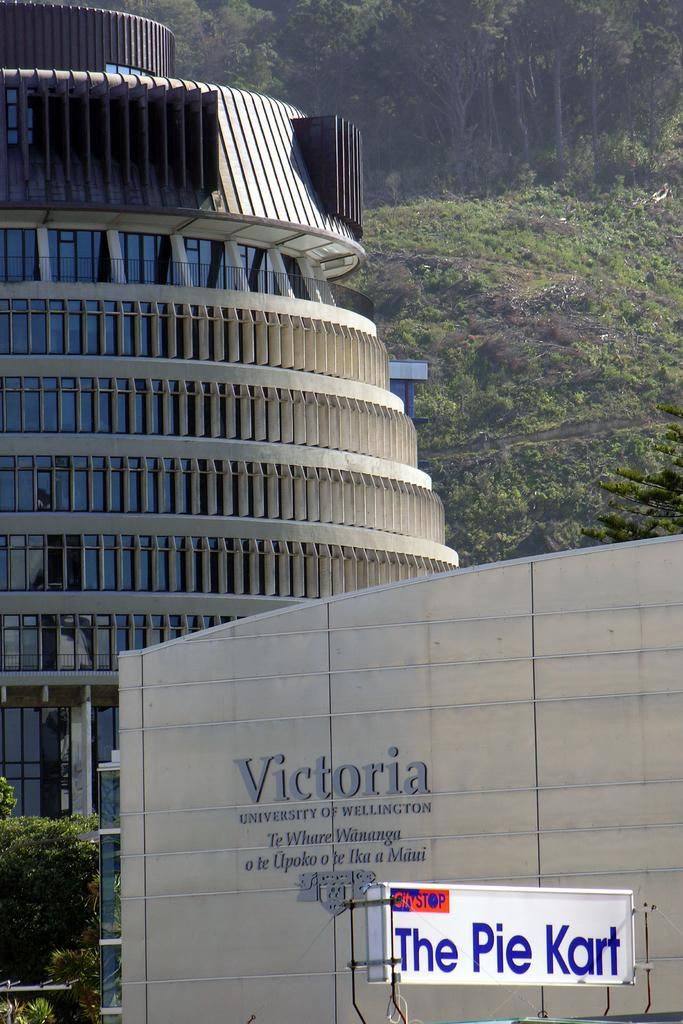What type of structures can be seen in the image? There are buildings in the image. What type of vegetation is present in the image? There are trees in the image. What type of signage can be seen in the image? There are hoardings in the image. What type of breakfast is being served on the stage in the image? There is no stage or breakfast present in the image. What type of queen is depicted on the hoarding in the image? There is no queen depicted on the hoarding in the image. 